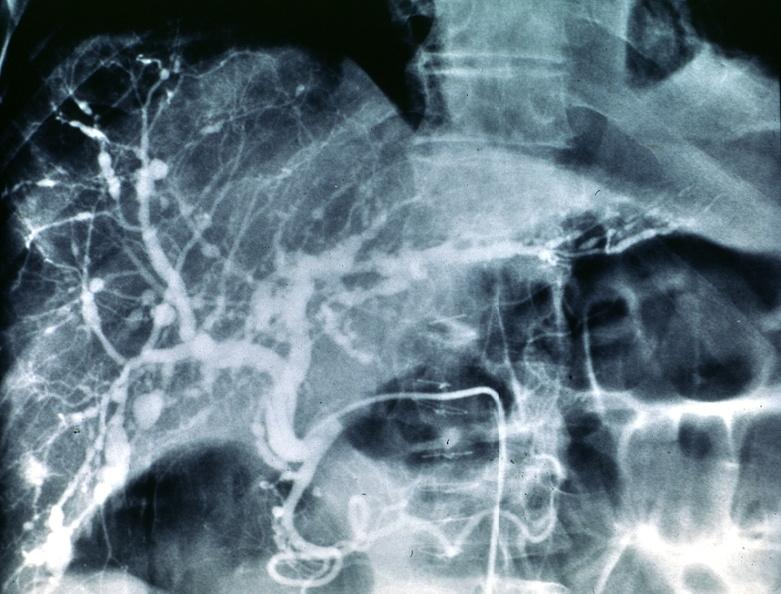s hepatobiliary present?
Answer the question using a single word or phrase. Yes 